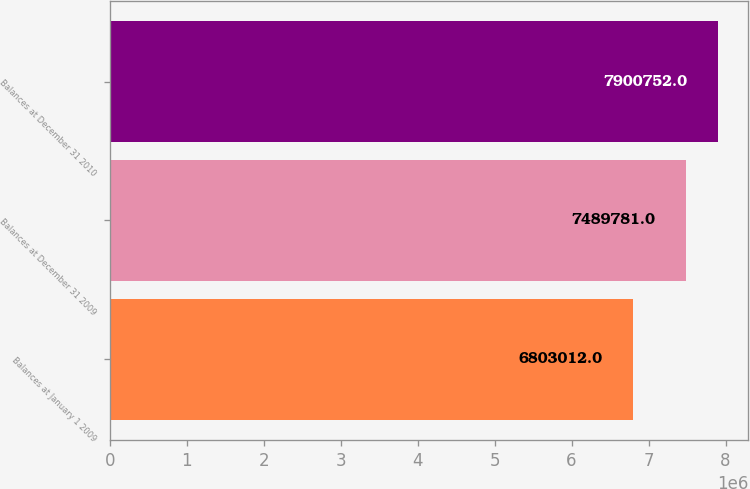Convert chart to OTSL. <chart><loc_0><loc_0><loc_500><loc_500><bar_chart><fcel>Balances at January 1 2009<fcel>Balances at December 31 2009<fcel>Balances at December 31 2010<nl><fcel>6.80301e+06<fcel>7.48978e+06<fcel>7.90075e+06<nl></chart> 